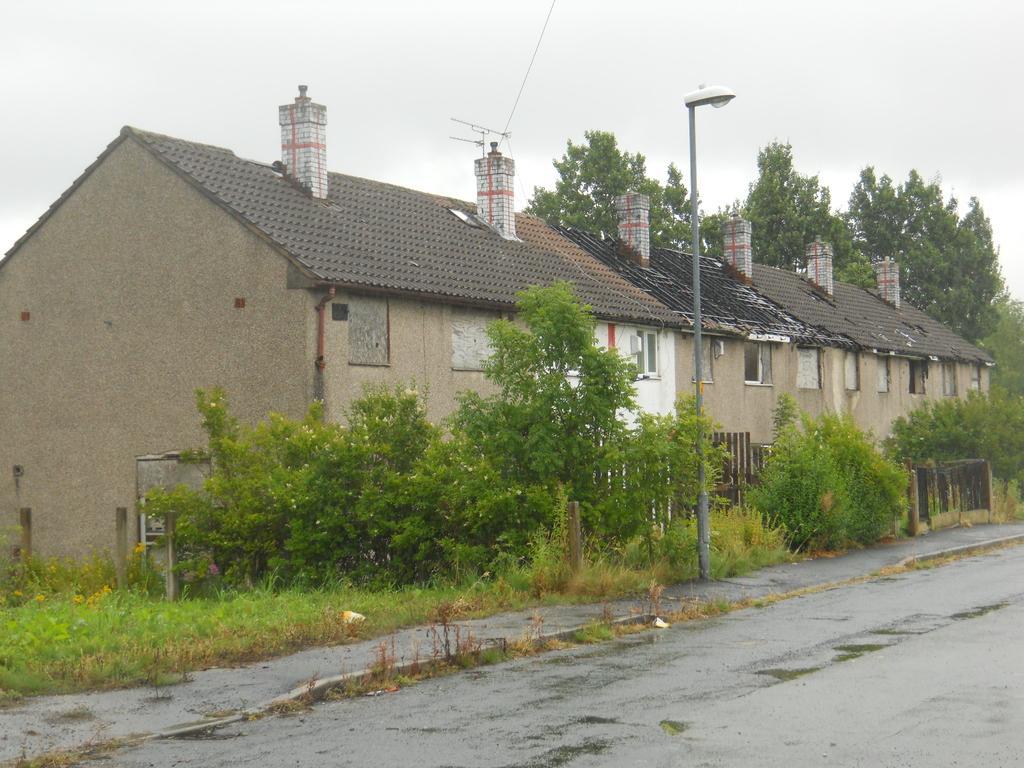Describe this image in one or two sentences. In the foreground of this image, there is a road. In the middle, there are trees, poles and a building. At the top, there is the sky. 